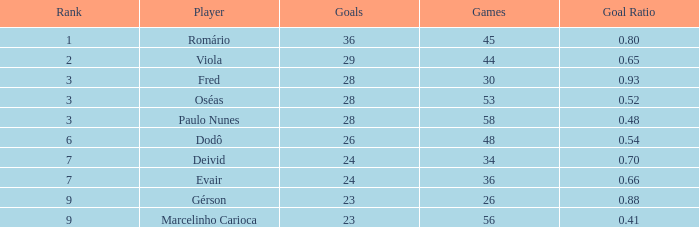How many goals have a goal ration less than 0.8 with 56 games? 1.0. 